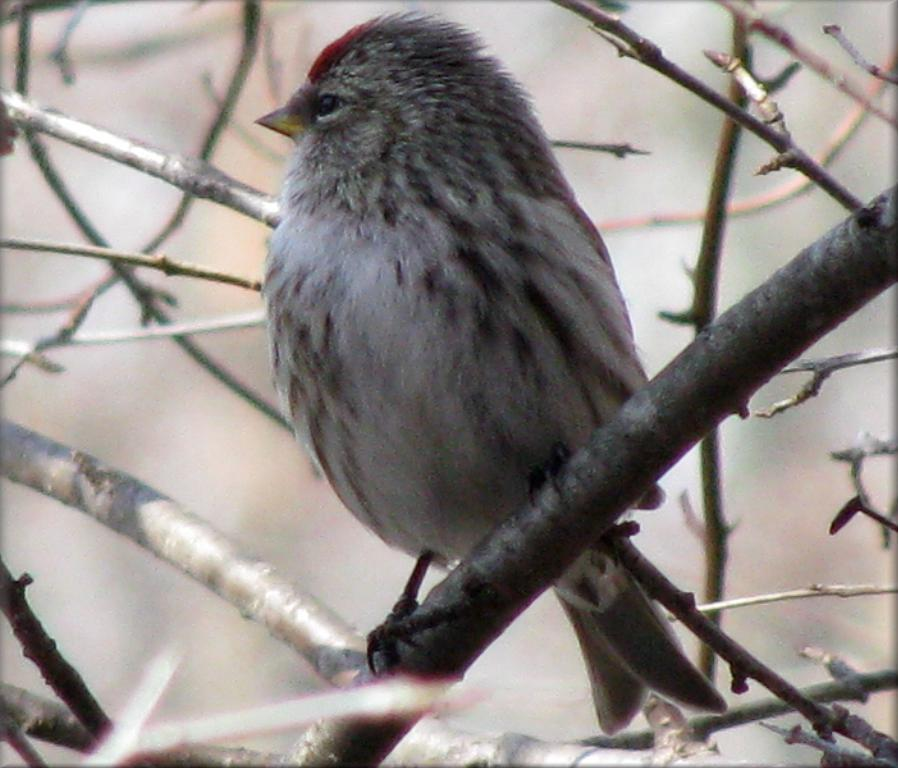What type of animal is in the image? There is a bird in the image. Where is the bird located? The bird is on a branch. What else can be seen in the image besides the bird? There are branches visible in the image. How would you describe the background of the image? The background of the image is blurred. What type of fruit is hanging from the branch next to the bird in the image? There is no fruit visible in the image; only the bird and branches are present. 